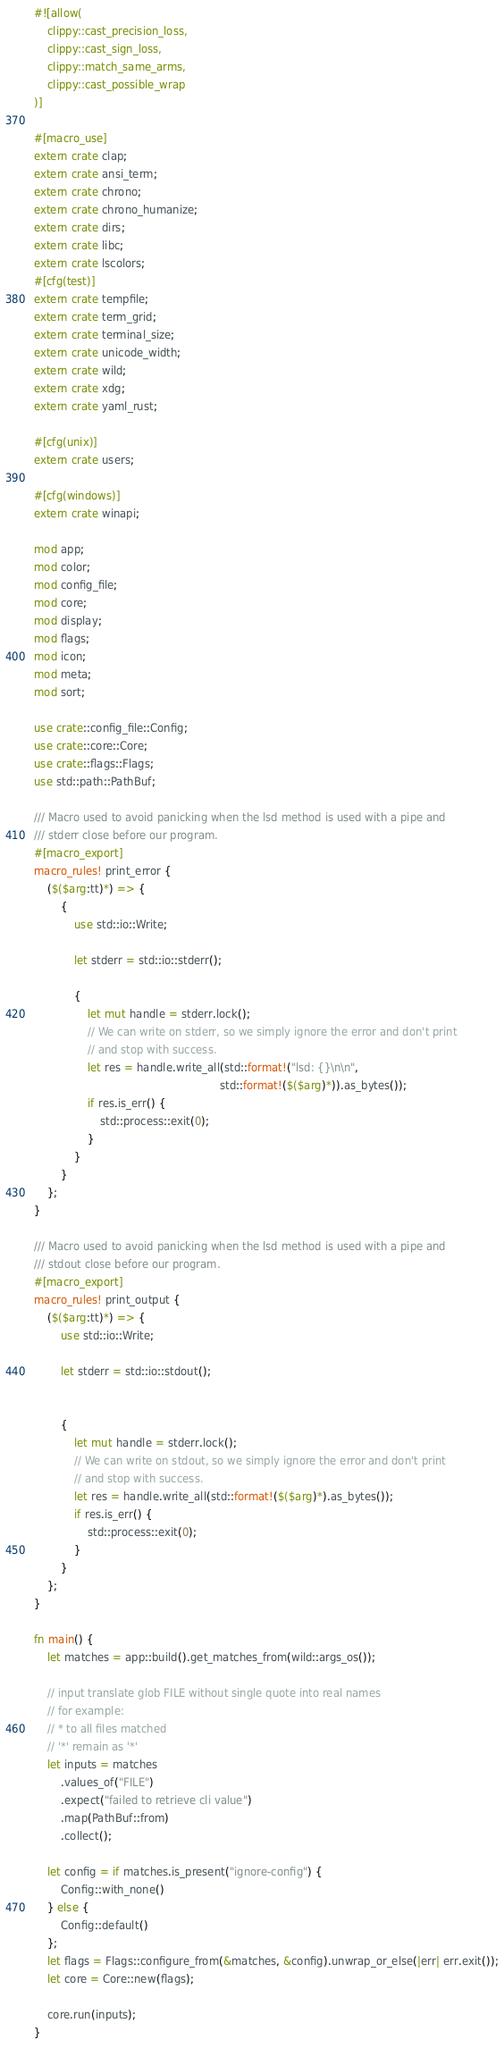<code> <loc_0><loc_0><loc_500><loc_500><_Rust_>#![allow(
    clippy::cast_precision_loss,
    clippy::cast_sign_loss,
    clippy::match_same_arms,
    clippy::cast_possible_wrap
)]

#[macro_use]
extern crate clap;
extern crate ansi_term;
extern crate chrono;
extern crate chrono_humanize;
extern crate dirs;
extern crate libc;
extern crate lscolors;
#[cfg(test)]
extern crate tempfile;
extern crate term_grid;
extern crate terminal_size;
extern crate unicode_width;
extern crate wild;
extern crate xdg;
extern crate yaml_rust;

#[cfg(unix)]
extern crate users;

#[cfg(windows)]
extern crate winapi;

mod app;
mod color;
mod config_file;
mod core;
mod display;
mod flags;
mod icon;
mod meta;
mod sort;

use crate::config_file::Config;
use crate::core::Core;
use crate::flags::Flags;
use std::path::PathBuf;

/// Macro used to avoid panicking when the lsd method is used with a pipe and
/// stderr close before our program.
#[macro_export]
macro_rules! print_error {
    ($($arg:tt)*) => {
        {
            use std::io::Write;

            let stderr = std::io::stderr();

            {
                let mut handle = stderr.lock();
                // We can write on stderr, so we simply ignore the error and don't print
                // and stop with success.
                let res = handle.write_all(std::format!("lsd: {}\n\n",
                                                        std::format!($($arg)*)).as_bytes());
                if res.is_err() {
                    std::process::exit(0);
                }
            }
        }
    };
}

/// Macro used to avoid panicking when the lsd method is used with a pipe and
/// stdout close before our program.
#[macro_export]
macro_rules! print_output {
    ($($arg:tt)*) => {
        use std::io::Write;

        let stderr = std::io::stdout();


        {
            let mut handle = stderr.lock();
            // We can write on stdout, so we simply ignore the error and don't print
            // and stop with success.
            let res = handle.write_all(std::format!($($arg)*).as_bytes());
            if res.is_err() {
                std::process::exit(0);
            }
        }
    };
}

fn main() {
    let matches = app::build().get_matches_from(wild::args_os());

    // input translate glob FILE without single quote into real names
    // for example:
    // * to all files matched
    // '*' remain as '*'
    let inputs = matches
        .values_of("FILE")
        .expect("failed to retrieve cli value")
        .map(PathBuf::from)
        .collect();

    let config = if matches.is_present("ignore-config") {
        Config::with_none()
    } else {
        Config::default()
    };
    let flags = Flags::configure_from(&matches, &config).unwrap_or_else(|err| err.exit());
    let core = Core::new(flags);

    core.run(inputs);
}
</code> 